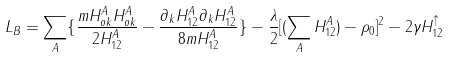<formula> <loc_0><loc_0><loc_500><loc_500>L _ { B } = \sum _ { A } \{ \frac { m H ^ { A } _ { o k } H ^ { A } _ { o k } } { 2 H ^ { A } _ { 1 2 } } - \frac { \partial _ { k } H ^ { A } _ { 1 2 } \partial _ { k } H ^ { A } _ { 1 2 } } { 8 m H ^ { A } _ { 1 2 } } \} - \frac { \lambda } { 2 } [ ( \sum _ { A } H ^ { A } _ { 1 2 } ) - \rho _ { 0 } ] ^ { 2 } - 2 \gamma H ^ { \uparrow } _ { 1 2 }</formula> 